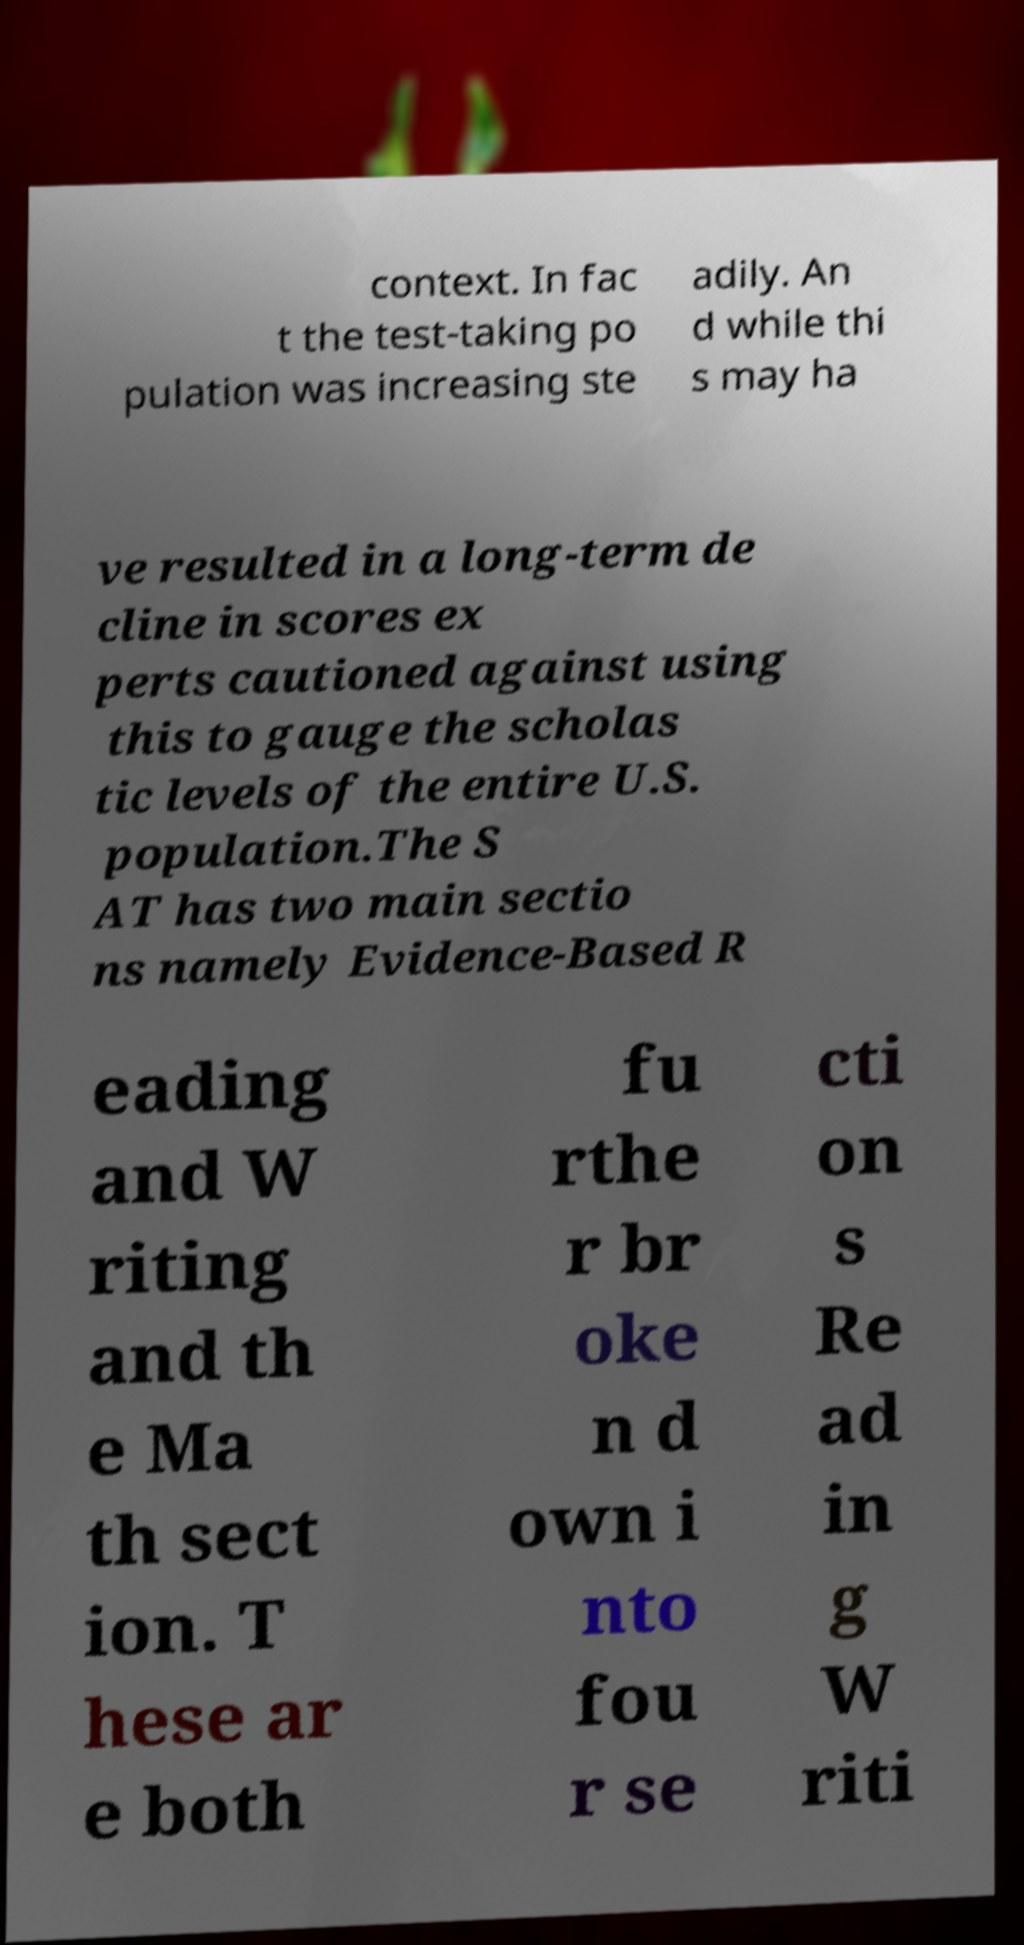Could you assist in decoding the text presented in this image and type it out clearly? context. In fac t the test-taking po pulation was increasing ste adily. An d while thi s may ha ve resulted in a long-term de cline in scores ex perts cautioned against using this to gauge the scholas tic levels of the entire U.S. population.The S AT has two main sectio ns namely Evidence-Based R eading and W riting and th e Ma th sect ion. T hese ar e both fu rthe r br oke n d own i nto fou r se cti on s Re ad in g W riti 